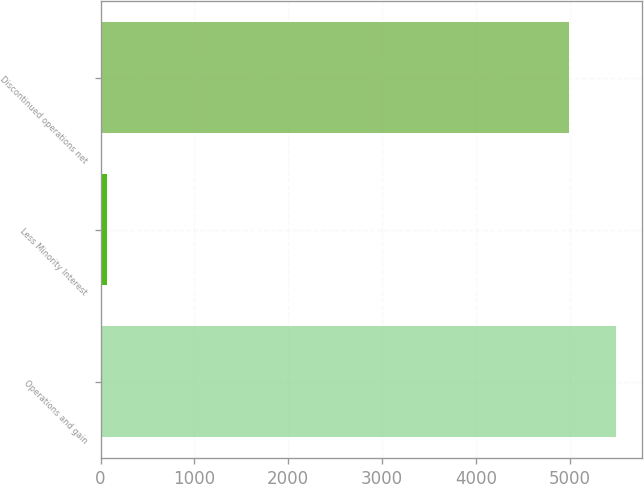<chart> <loc_0><loc_0><loc_500><loc_500><bar_chart><fcel>Operations and gain<fcel>Less Minority Interest<fcel>Discontinued operations net<nl><fcel>5498.9<fcel>68<fcel>4999<nl></chart> 